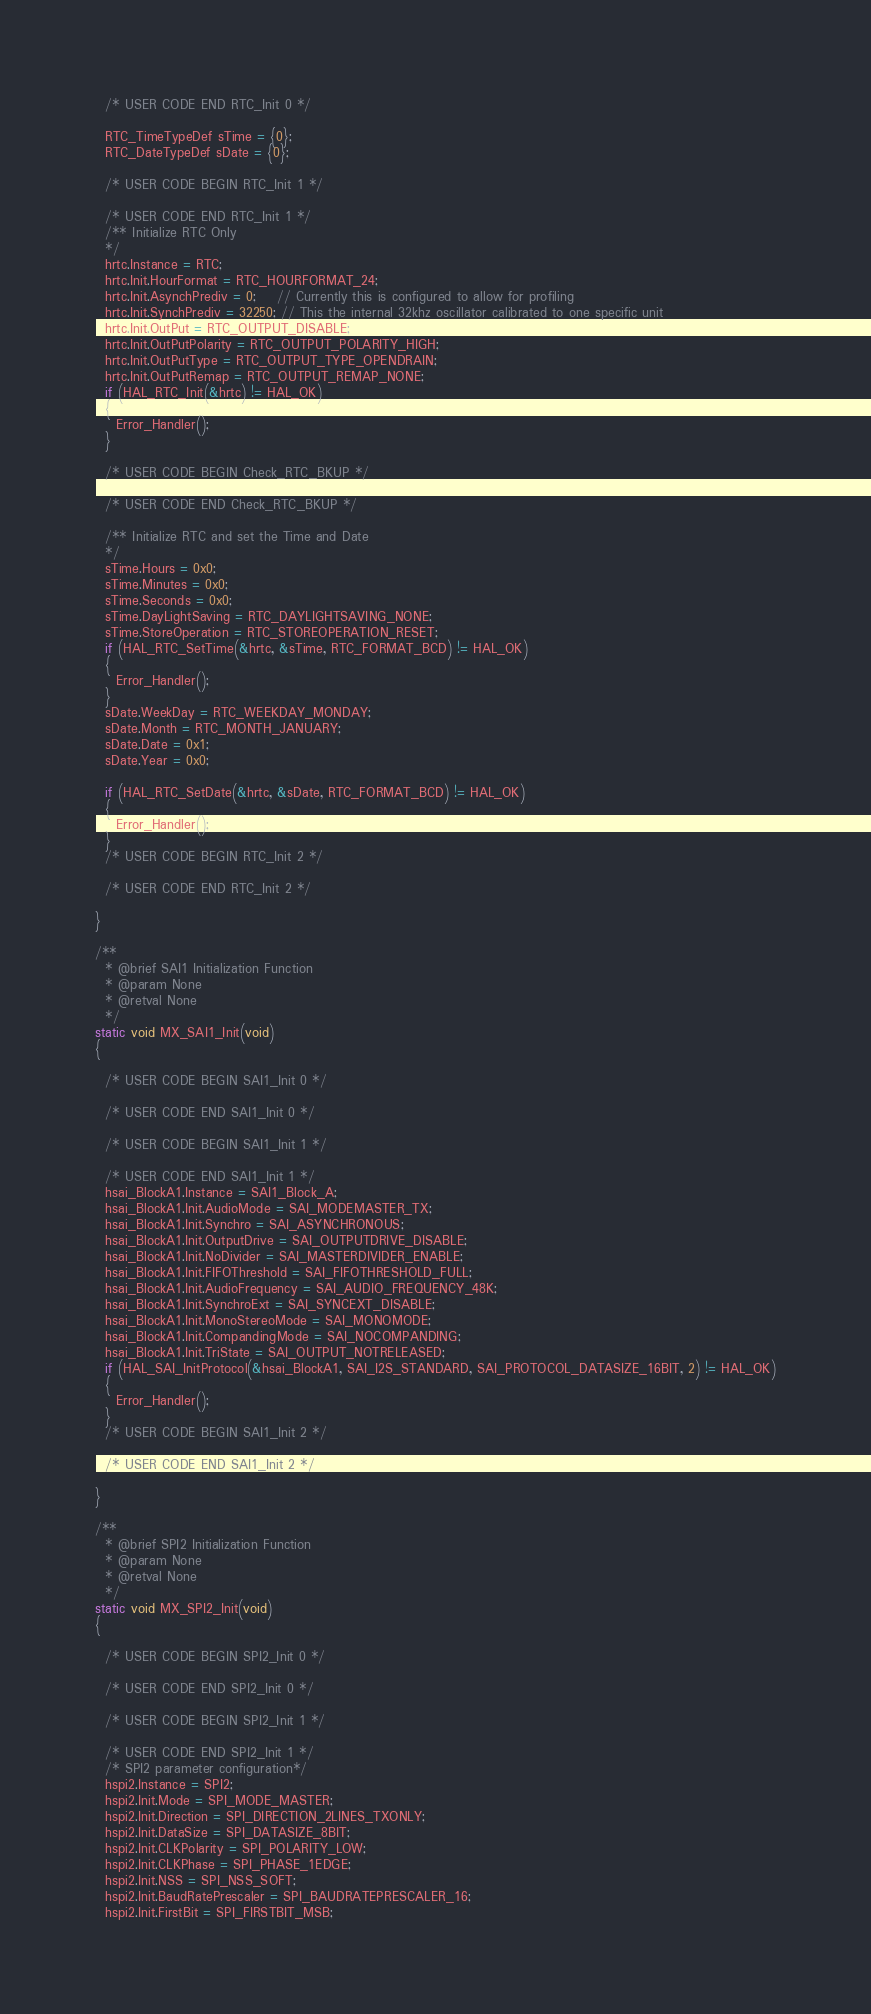<code> <loc_0><loc_0><loc_500><loc_500><_C_>  /* USER CODE END RTC_Init 0 */

  RTC_TimeTypeDef sTime = {0};
  RTC_DateTypeDef sDate = {0};

  /* USER CODE BEGIN RTC_Init 1 */

  /* USER CODE END RTC_Init 1 */
  /** Initialize RTC Only
  */
  hrtc.Instance = RTC;
  hrtc.Init.HourFormat = RTC_HOURFORMAT_24;
  hrtc.Init.AsynchPrediv = 0;    // Currently this is configured to allow for profiling
  hrtc.Init.SynchPrediv = 32250; // This the internal 32khz oscillator calibrated to one specific unit
  hrtc.Init.OutPut = RTC_OUTPUT_DISABLE;
  hrtc.Init.OutPutPolarity = RTC_OUTPUT_POLARITY_HIGH;
  hrtc.Init.OutPutType = RTC_OUTPUT_TYPE_OPENDRAIN;
  hrtc.Init.OutPutRemap = RTC_OUTPUT_REMAP_NONE;
  if (HAL_RTC_Init(&hrtc) != HAL_OK)
  {
    Error_Handler();
  }

  /* USER CODE BEGIN Check_RTC_BKUP */

  /* USER CODE END Check_RTC_BKUP */

  /** Initialize RTC and set the Time and Date
  */
  sTime.Hours = 0x0;
  sTime.Minutes = 0x0;
  sTime.Seconds = 0x0;
  sTime.DayLightSaving = RTC_DAYLIGHTSAVING_NONE;
  sTime.StoreOperation = RTC_STOREOPERATION_RESET;
  if (HAL_RTC_SetTime(&hrtc, &sTime, RTC_FORMAT_BCD) != HAL_OK)
  {
    Error_Handler();
  }
  sDate.WeekDay = RTC_WEEKDAY_MONDAY;
  sDate.Month = RTC_MONTH_JANUARY;
  sDate.Date = 0x1;
  sDate.Year = 0x0;

  if (HAL_RTC_SetDate(&hrtc, &sDate, RTC_FORMAT_BCD) != HAL_OK)
  {
    Error_Handler();
  }
  /* USER CODE BEGIN RTC_Init 2 */

  /* USER CODE END RTC_Init 2 */

}

/**
  * @brief SAI1 Initialization Function
  * @param None
  * @retval None
  */
static void MX_SAI1_Init(void)
{

  /* USER CODE BEGIN SAI1_Init 0 */

  /* USER CODE END SAI1_Init 0 */

  /* USER CODE BEGIN SAI1_Init 1 */

  /* USER CODE END SAI1_Init 1 */
  hsai_BlockA1.Instance = SAI1_Block_A;
  hsai_BlockA1.Init.AudioMode = SAI_MODEMASTER_TX;
  hsai_BlockA1.Init.Synchro = SAI_ASYNCHRONOUS;
  hsai_BlockA1.Init.OutputDrive = SAI_OUTPUTDRIVE_DISABLE;
  hsai_BlockA1.Init.NoDivider = SAI_MASTERDIVIDER_ENABLE;
  hsai_BlockA1.Init.FIFOThreshold = SAI_FIFOTHRESHOLD_FULL;
  hsai_BlockA1.Init.AudioFrequency = SAI_AUDIO_FREQUENCY_48K;
  hsai_BlockA1.Init.SynchroExt = SAI_SYNCEXT_DISABLE;
  hsai_BlockA1.Init.MonoStereoMode = SAI_MONOMODE;
  hsai_BlockA1.Init.CompandingMode = SAI_NOCOMPANDING;
  hsai_BlockA1.Init.TriState = SAI_OUTPUT_NOTRELEASED;
  if (HAL_SAI_InitProtocol(&hsai_BlockA1, SAI_I2S_STANDARD, SAI_PROTOCOL_DATASIZE_16BIT, 2) != HAL_OK)
  {
    Error_Handler();
  }
  /* USER CODE BEGIN SAI1_Init 2 */

  /* USER CODE END SAI1_Init 2 */

}

/**
  * @brief SPI2 Initialization Function
  * @param None
  * @retval None
  */
static void MX_SPI2_Init(void)
{

  /* USER CODE BEGIN SPI2_Init 0 */

  /* USER CODE END SPI2_Init 0 */

  /* USER CODE BEGIN SPI2_Init 1 */

  /* USER CODE END SPI2_Init 1 */
  /* SPI2 parameter configuration*/
  hspi2.Instance = SPI2;
  hspi2.Init.Mode = SPI_MODE_MASTER;
  hspi2.Init.Direction = SPI_DIRECTION_2LINES_TXONLY;
  hspi2.Init.DataSize = SPI_DATASIZE_8BIT;
  hspi2.Init.CLKPolarity = SPI_POLARITY_LOW;
  hspi2.Init.CLKPhase = SPI_PHASE_1EDGE;
  hspi2.Init.NSS = SPI_NSS_SOFT;
  hspi2.Init.BaudRatePrescaler = SPI_BAUDRATEPRESCALER_16;
  hspi2.Init.FirstBit = SPI_FIRSTBIT_MSB;</code> 